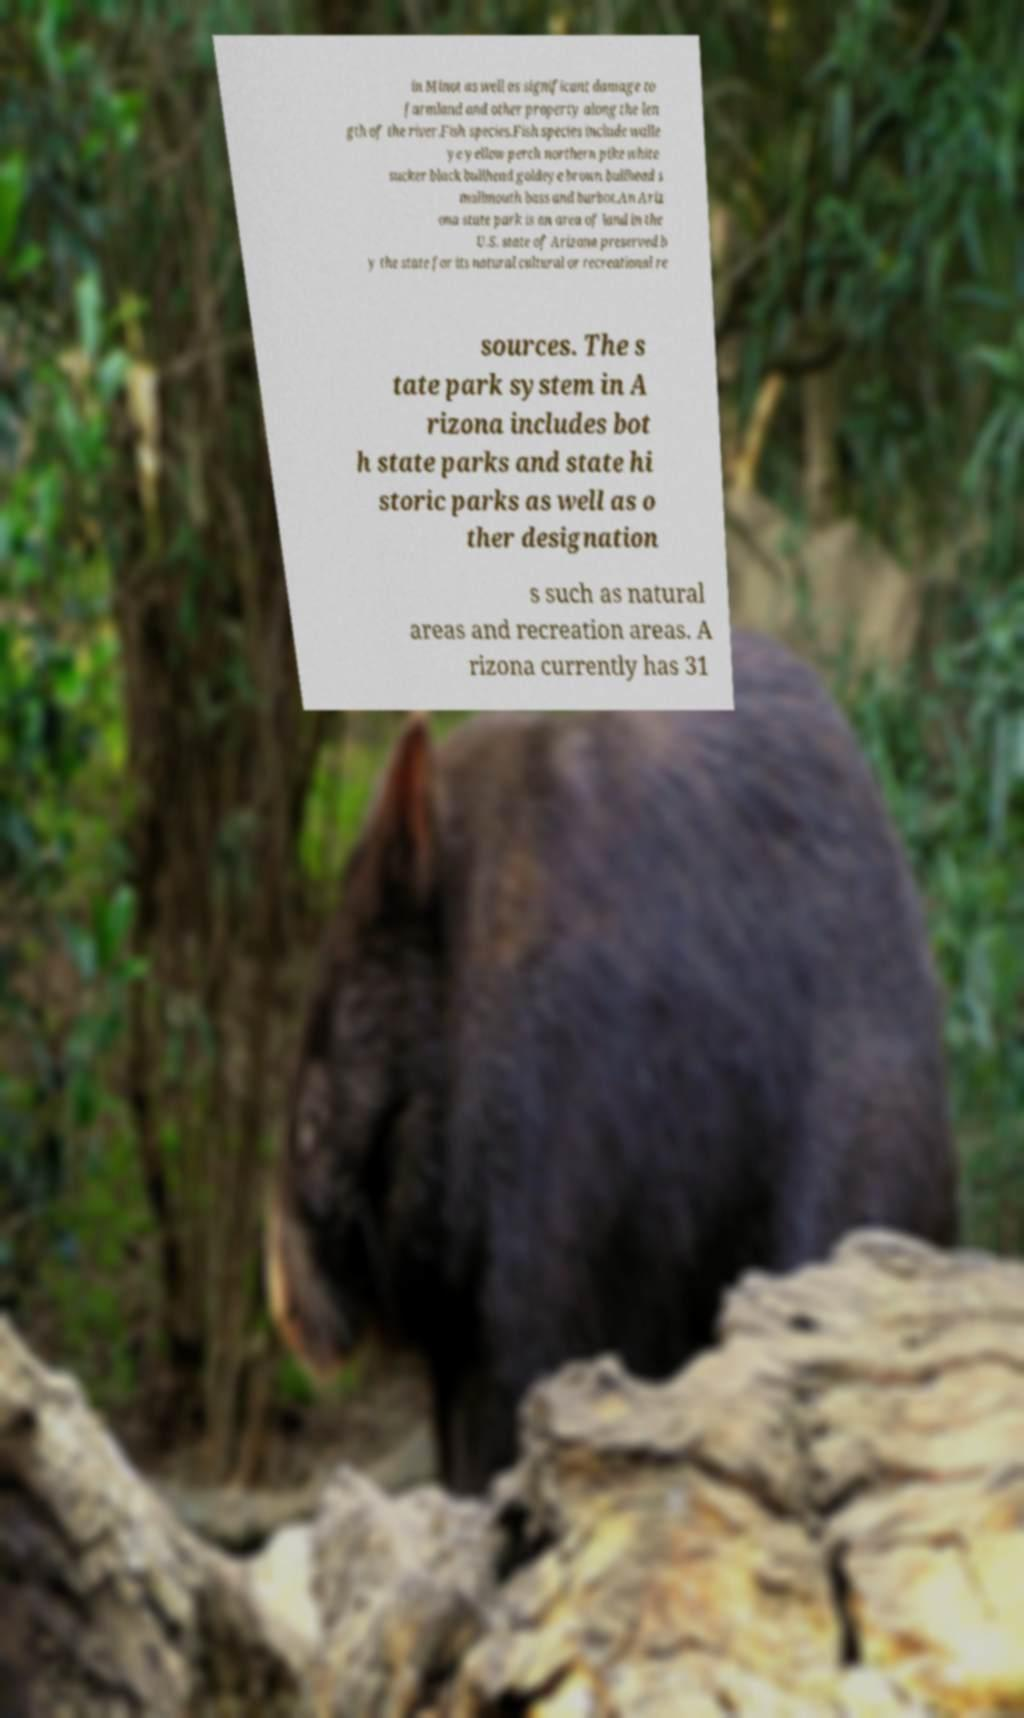For documentation purposes, I need the text within this image transcribed. Could you provide that? in Minot as well as significant damage to farmland and other property along the len gth of the river.Fish species.Fish species include walle ye yellow perch northern pike white sucker black bullhead goldeye brown bullhead s mallmouth bass and burbot.An Ariz ona state park is an area of land in the U.S. state of Arizona preserved b y the state for its natural cultural or recreational re sources. The s tate park system in A rizona includes bot h state parks and state hi storic parks as well as o ther designation s such as natural areas and recreation areas. A rizona currently has 31 